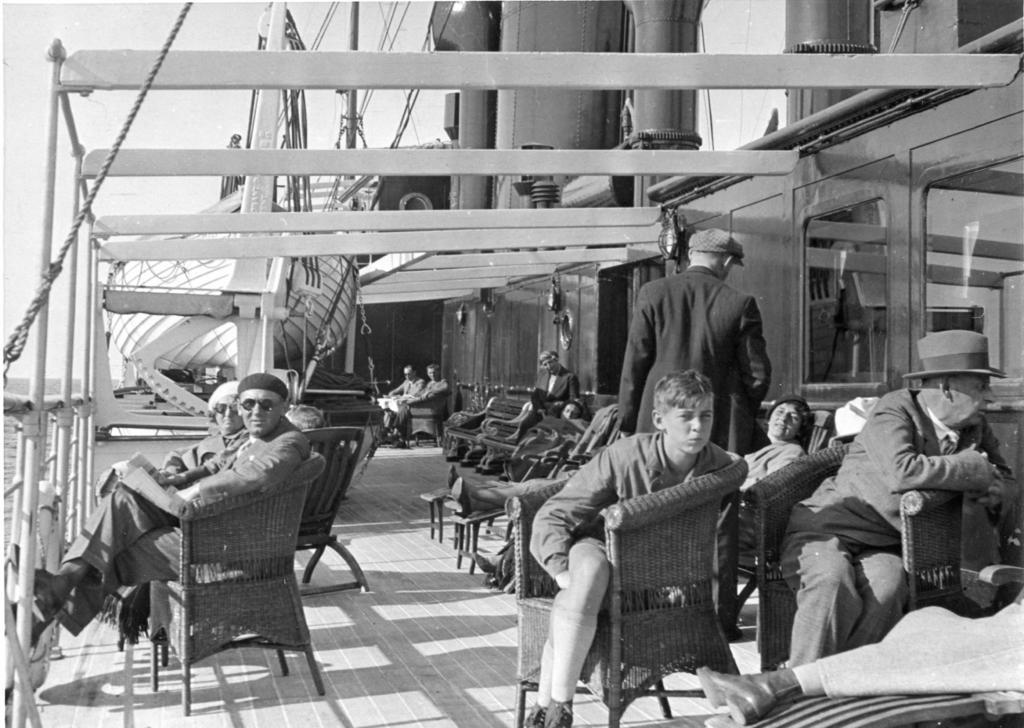What is the main subject of the image? The main subject of the image is a boat. What can be seen inside the boat? There are people sitting on chairs in the boat. What is the rate at which the drum is being played in the image? There is no drum present in the image, so it is not possible to determine the rate at which it might be played. 